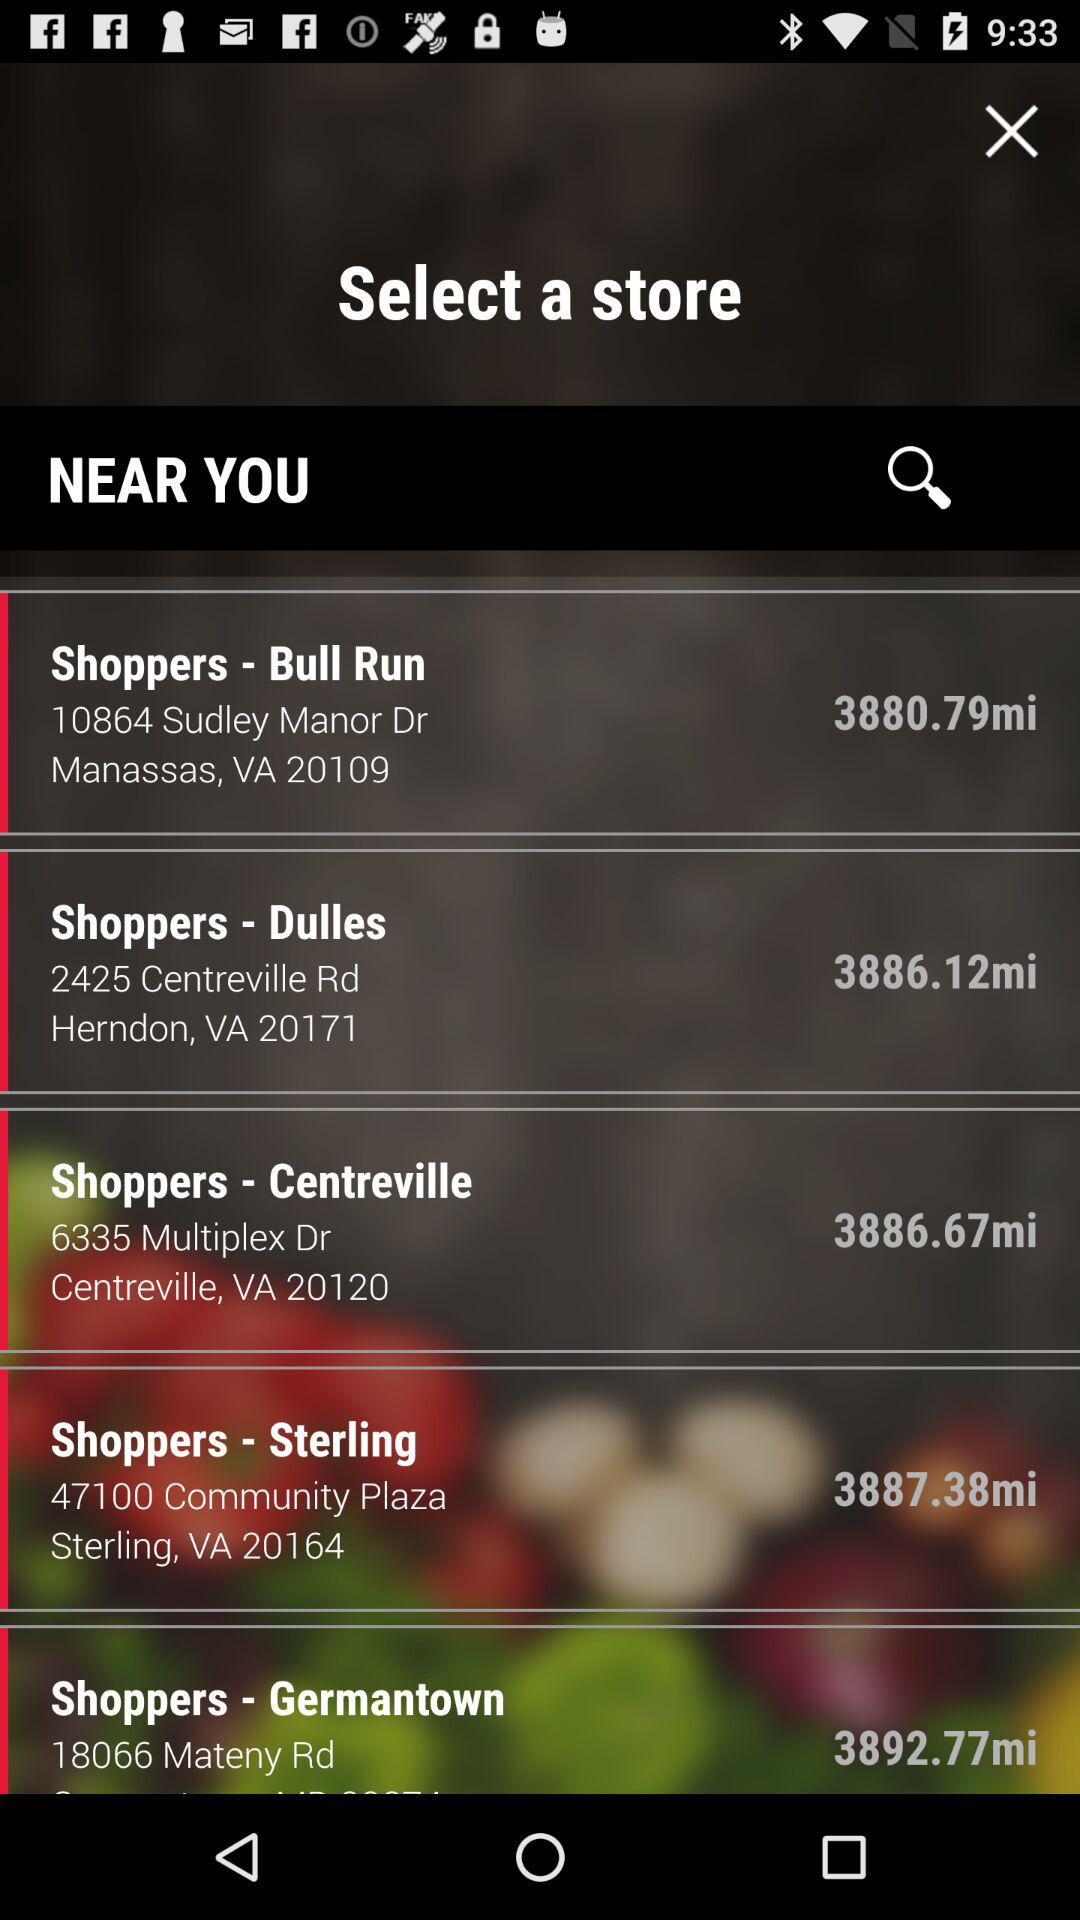Which store is located near Community Plaza, Sterling, VA? The store located near Community Plaza, Sterling, VA is "Shoppers". 